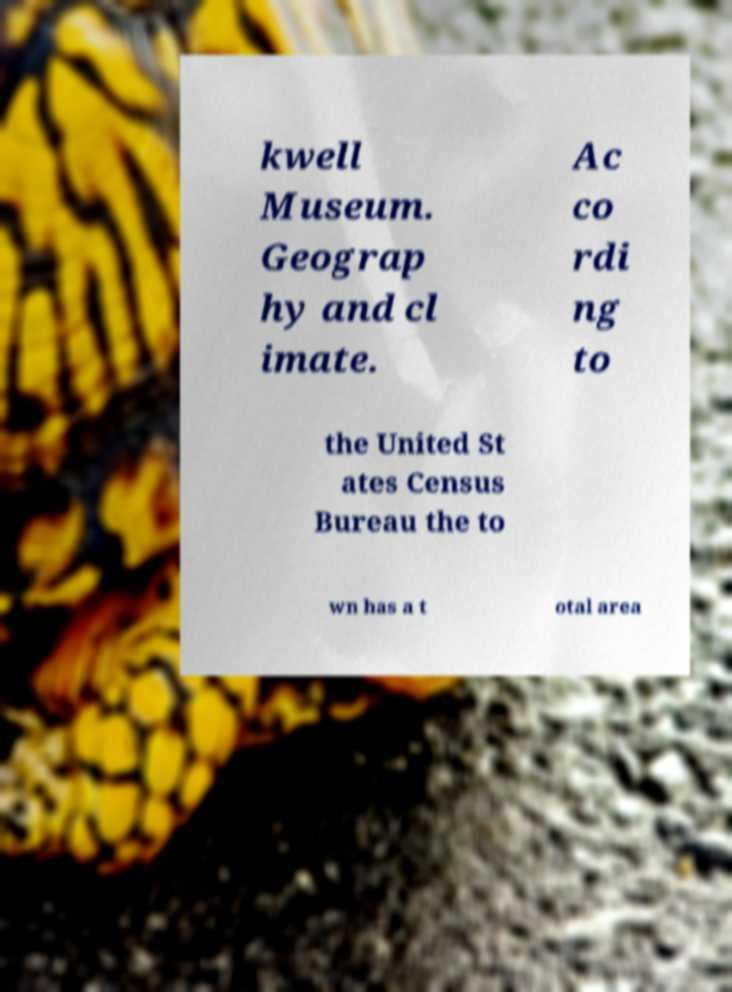I need the written content from this picture converted into text. Can you do that? kwell Museum. Geograp hy and cl imate. Ac co rdi ng to the United St ates Census Bureau the to wn has a t otal area 